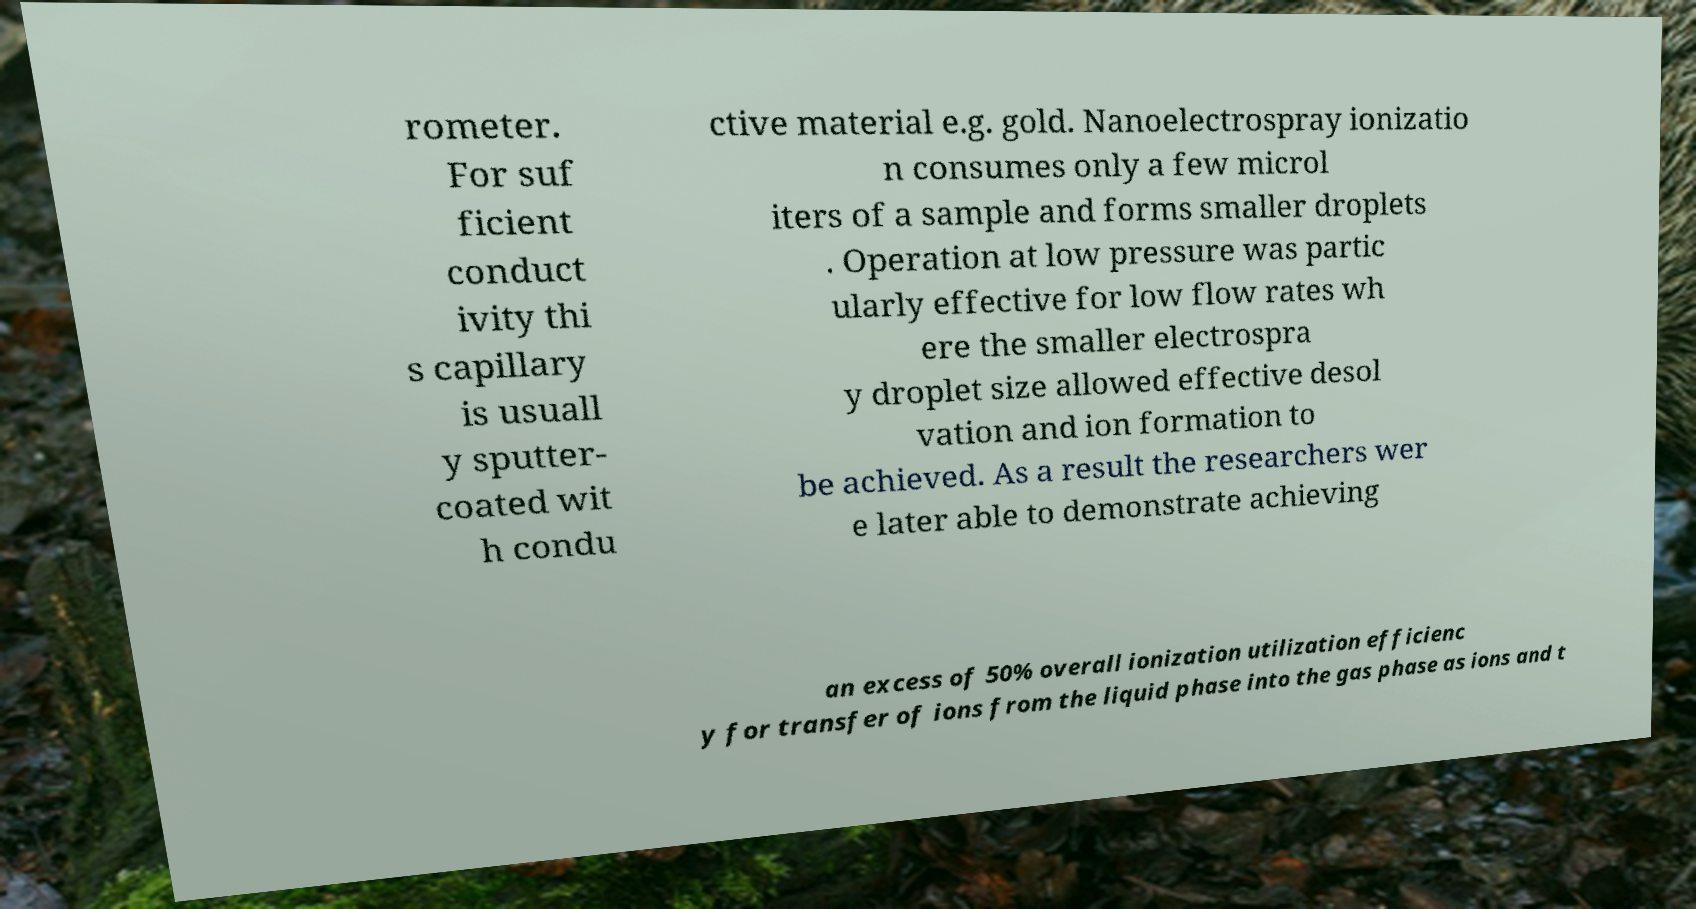Could you extract and type out the text from this image? rometer. For suf ficient conduct ivity thi s capillary is usuall y sputter- coated wit h condu ctive material e.g. gold. Nanoelectrospray ionizatio n consumes only a few microl iters of a sample and forms smaller droplets . Operation at low pressure was partic ularly effective for low flow rates wh ere the smaller electrospra y droplet size allowed effective desol vation and ion formation to be achieved. As a result the researchers wer e later able to demonstrate achieving an excess of 50% overall ionization utilization efficienc y for transfer of ions from the liquid phase into the gas phase as ions and t 